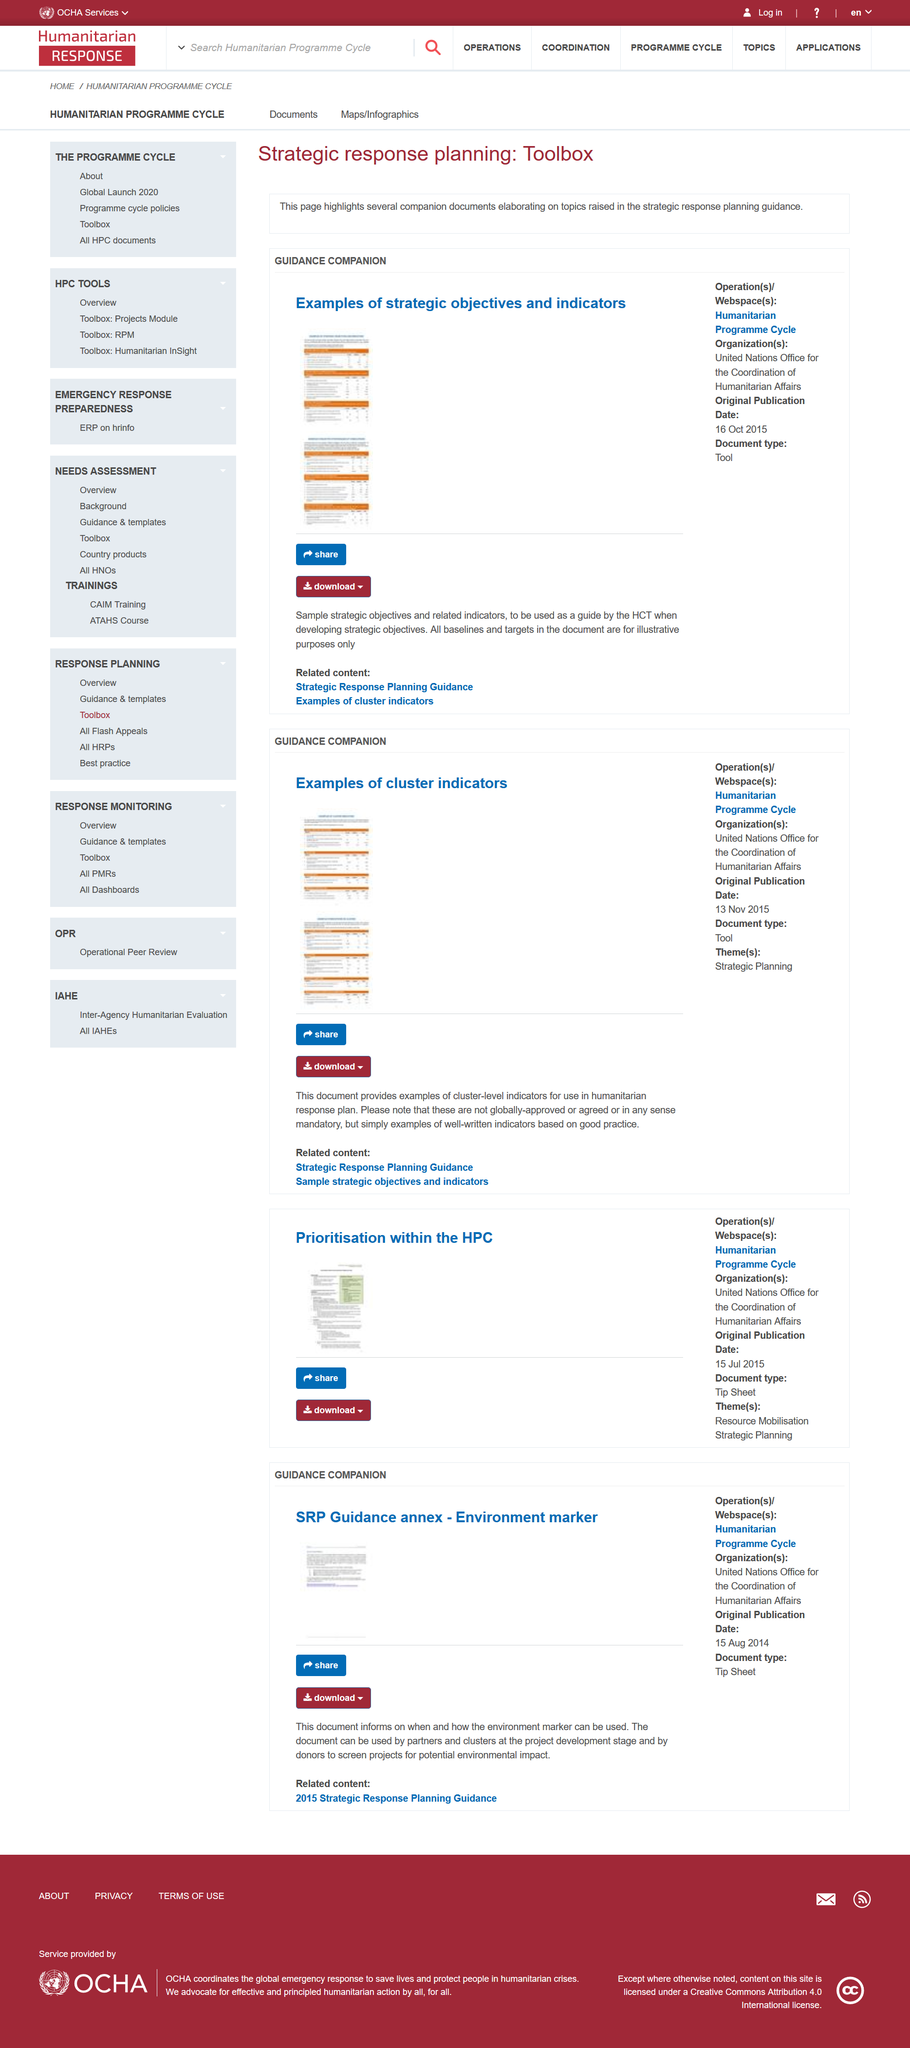Point out several critical features in this image. The United Nations Office for the Coordination of Humanitarian Affairs is the owner of the Humanitarian Programme Cycle webspace. The United Nations published a document called "Examples of Strategic Objectives and Indicators" on October 16th, 2015, which was originally published. On November 13th, 2015, the United Nations first released a document titled "Examples of Cluster Indicators. 